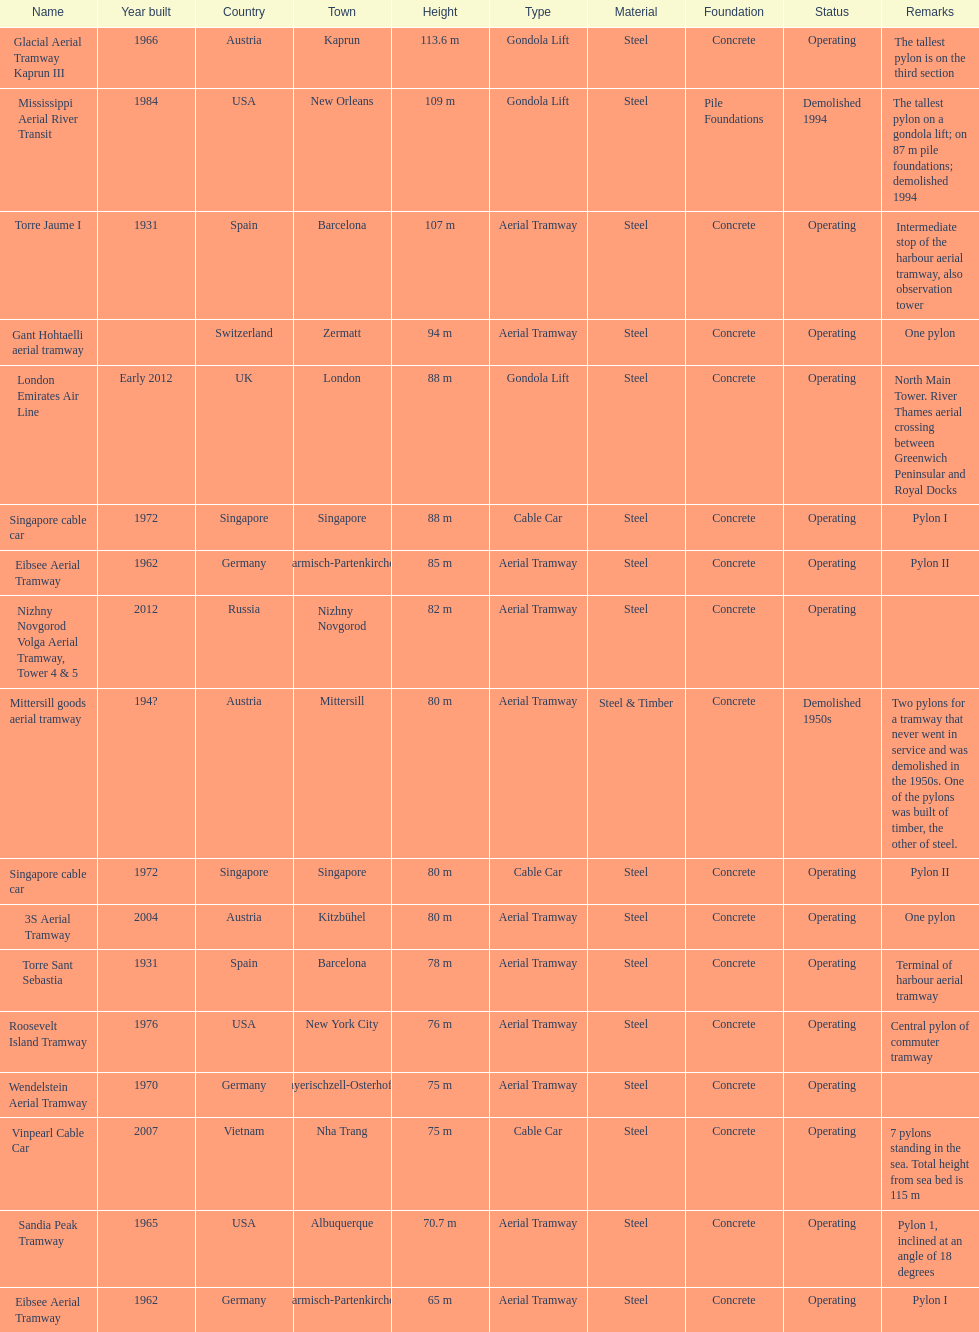How many pylons are in austria? 3. 